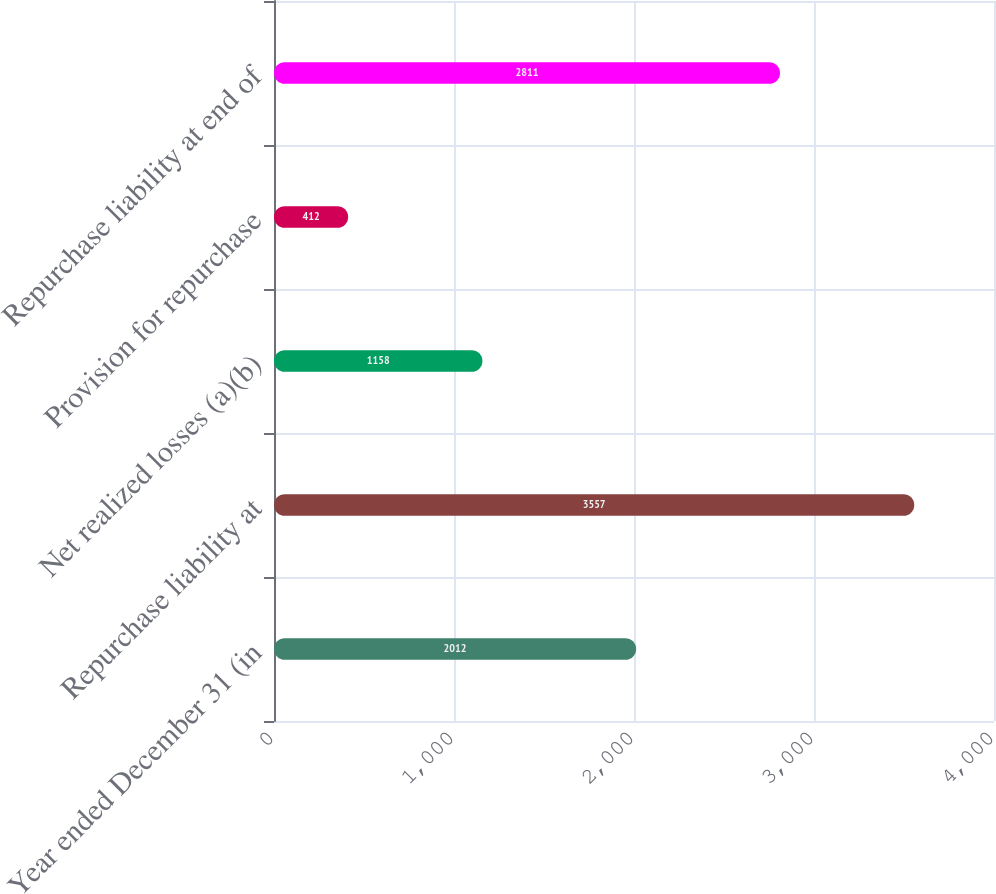<chart> <loc_0><loc_0><loc_500><loc_500><bar_chart><fcel>Year ended December 31 (in<fcel>Repurchase liability at<fcel>Net realized losses (a)(b)<fcel>Provision for repurchase<fcel>Repurchase liability at end of<nl><fcel>2012<fcel>3557<fcel>1158<fcel>412<fcel>2811<nl></chart> 